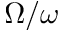<formula> <loc_0><loc_0><loc_500><loc_500>\Omega / \omega</formula> 